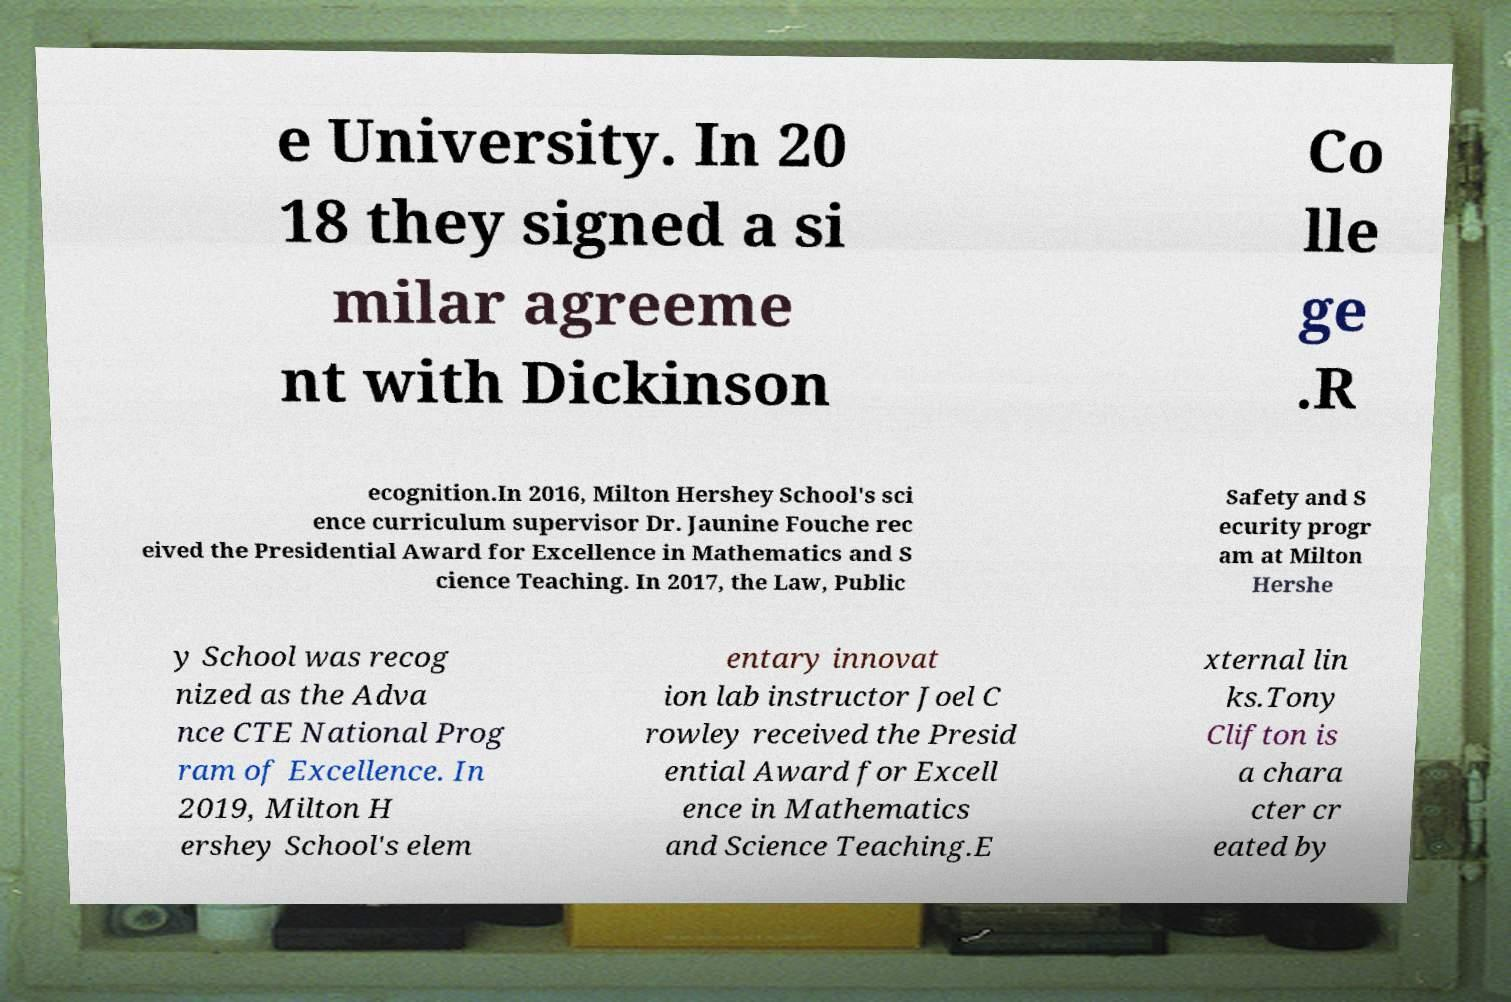There's text embedded in this image that I need extracted. Can you transcribe it verbatim? e University. In 20 18 they signed a si milar agreeme nt with Dickinson Co lle ge .R ecognition.In 2016, Milton Hershey School's sci ence curriculum supervisor Dr. Jaunine Fouche rec eived the Presidential Award for Excellence in Mathematics and S cience Teaching. In 2017, the Law, Public Safety and S ecurity progr am at Milton Hershe y School was recog nized as the Adva nce CTE National Prog ram of Excellence. In 2019, Milton H ershey School's elem entary innovat ion lab instructor Joel C rowley received the Presid ential Award for Excell ence in Mathematics and Science Teaching.E xternal lin ks.Tony Clifton is a chara cter cr eated by 